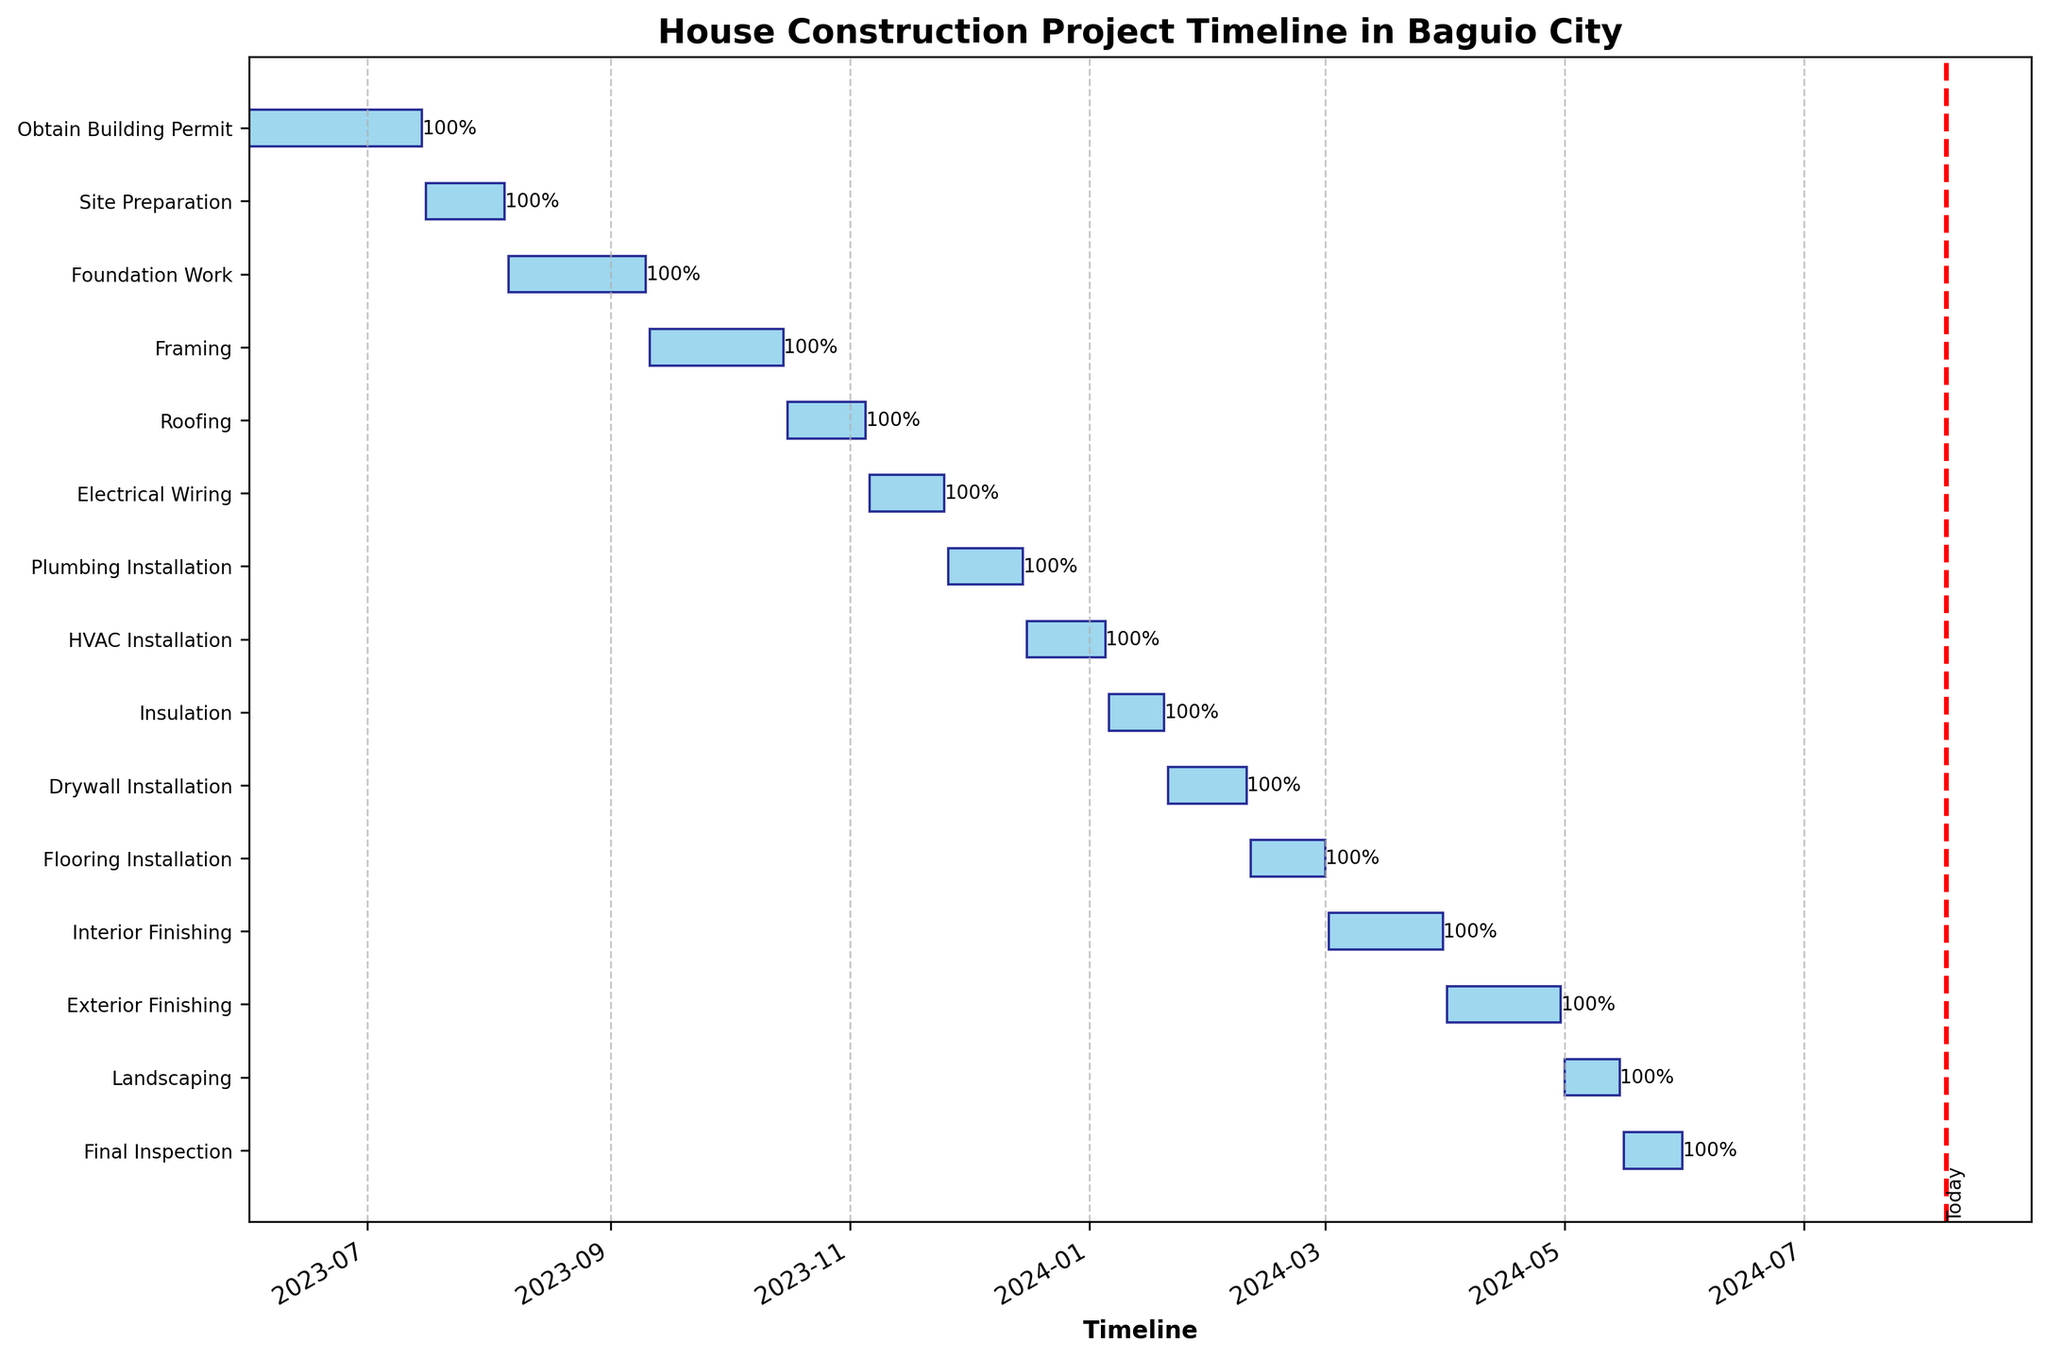What is the title of the figure? The title of a figure is typically located at the top of the chart, summarizing the visual's content. Here, it's placed at the top center.
Answer: House Construction Project Timeline in Baguio City When does the "Framing" phase begin and end? Check the horizontal bars corresponding to "Framing" along with its left and right ends for the start and end dates respectively.
Answer: 2023-09-11, 2023-10-15 How long does the "Roofing" phase last? Measure the duration of the "Roofing" task by calculating the difference between its start and end dates.
Answer: 20 days Which task directly follows "Foundation Work"? Identify the task listed immediately below "Foundation Work" to understand the sequencing.
Answer: Framing How many tasks are scheduled to be completed in 2024? Review the end dates of each task and count how many conclude in the year 2024.
Answer: 9 tasks Which task finishes on the earliest date, and when is that? Look for the task with the earliest end date on the Gantt chart and note down the date.
Answer: Obtain Building Permit, 2023-07-15 What's the combined duration of the "Electrical Wiring" and "Plumbing Installation" phases? Add the durations of "Electrical Wiring" and "Plumbing Installation" by calculating the difference between their start and end dates respectively, then summing them up.
Answer: 20 days Which phase is currently in progress? Cross-reference the current date indicated by the red line with the active phases by checking their start and end dates.
Answer: Electrical Wiring How much time is allocated between the end of "Site Preparation" and start of "Foundation Work"? Calculate the difference in days between the end date of "Site Preparation" and the start date of "Foundation Work".
Answer: 1 day Is the "Drywall Installation" phase longer or shorter than the "Insulation" phase? Compare the durations of "Drywall Installation" and "Insulation" by subtracting their start dates from their end dates to see which is longer.
Answer: Longer 